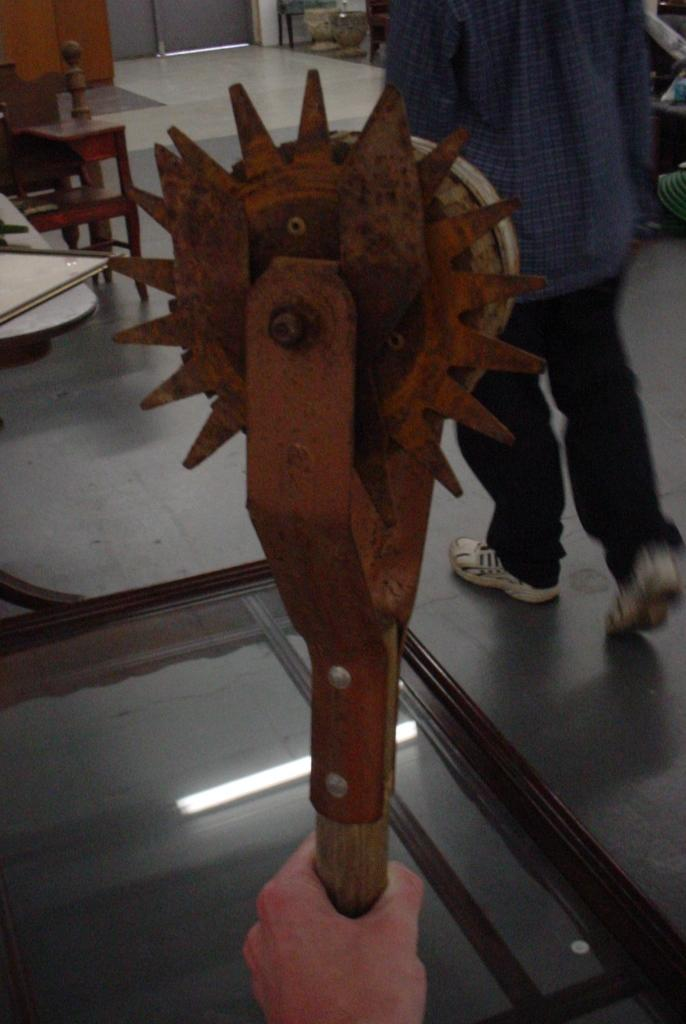What type of object can be seen in the image? There is a wheel-type object in the image. Can you describe the person in the image? There is a person walking on the right side of the image. What type of zipper is being used by the governor in the image? There is no governor or zipper present in the image. 